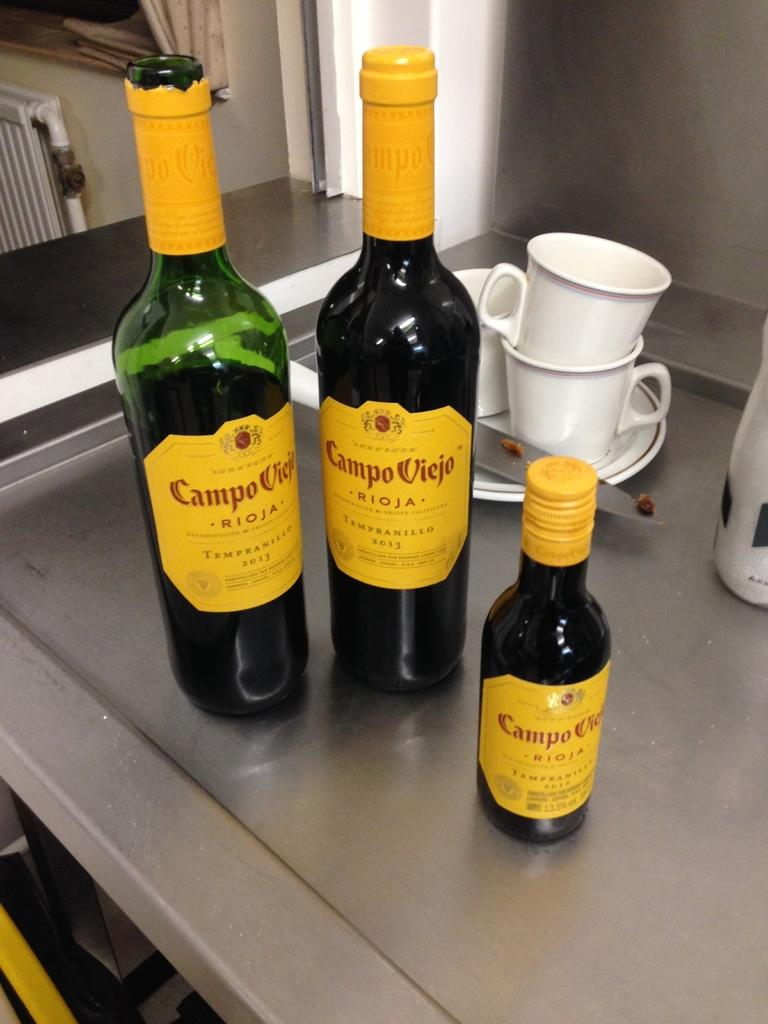<image>
Summarize the visual content of the image. the word campo is on the wine bottle 